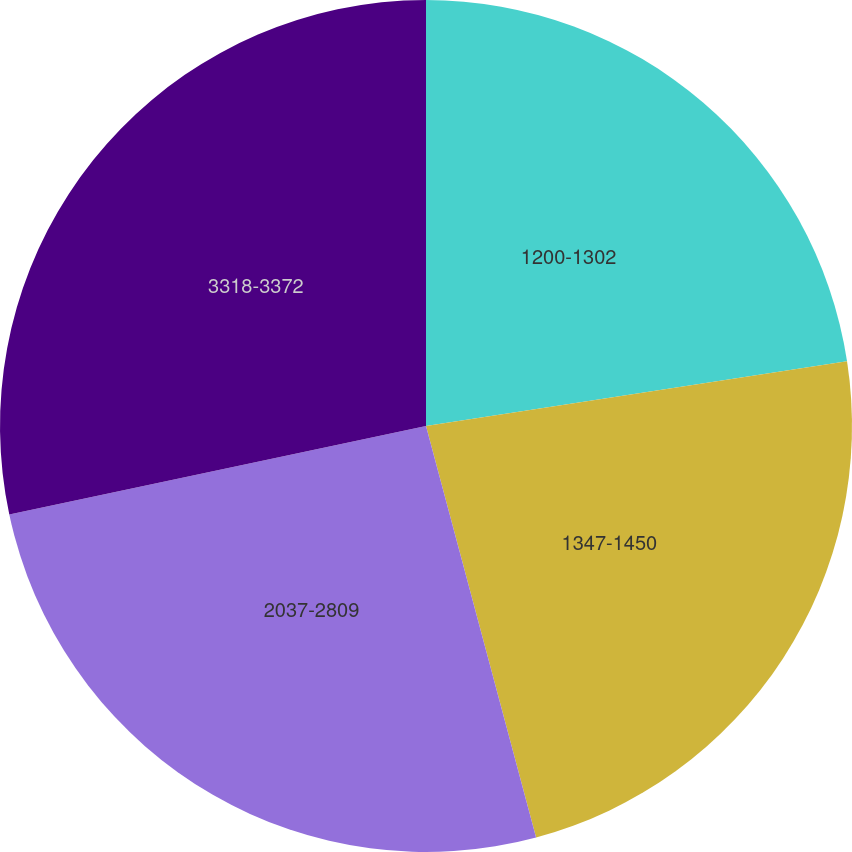<chart> <loc_0><loc_0><loc_500><loc_500><pie_chart><fcel>1200-1302<fcel>1347-1450<fcel>2037-2809<fcel>3318-3372<nl><fcel>22.57%<fcel>23.27%<fcel>25.83%<fcel>28.33%<nl></chart> 